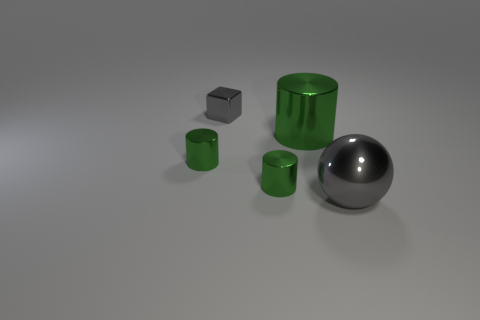Subtract all small metal cylinders. How many cylinders are left? 1 Add 4 large blue rubber cubes. How many objects exist? 9 Subtract all cylinders. How many objects are left? 2 Subtract all purple blocks. Subtract all red cylinders. How many blocks are left? 1 Subtract all green cylinders. How many purple cubes are left? 0 Subtract all small gray objects. Subtract all tiny gray metal blocks. How many objects are left? 3 Add 3 metallic balls. How many metallic balls are left? 4 Add 4 green cylinders. How many green cylinders exist? 7 Subtract 0 red cubes. How many objects are left? 5 